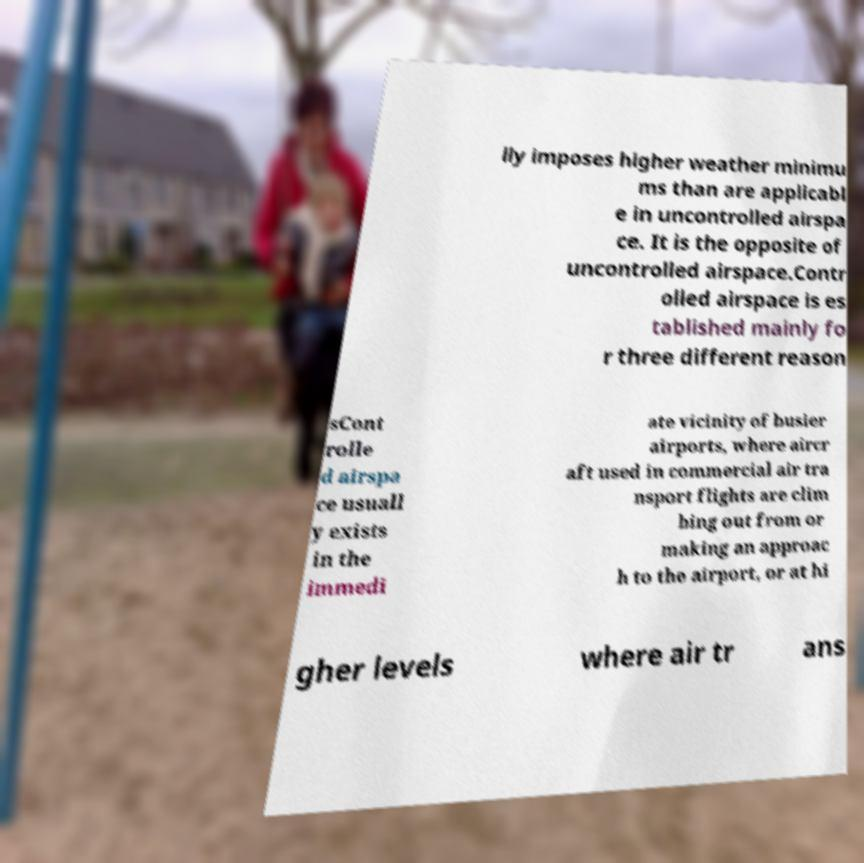Could you extract and type out the text from this image? lly imposes higher weather minimu ms than are applicabl e in uncontrolled airspa ce. It is the opposite of uncontrolled airspace.Contr olled airspace is es tablished mainly fo r three different reason sCont rolle d airspa ce usuall y exists in the immedi ate vicinity of busier airports, where aircr aft used in commercial air tra nsport flights are clim bing out from or making an approac h to the airport, or at hi gher levels where air tr ans 